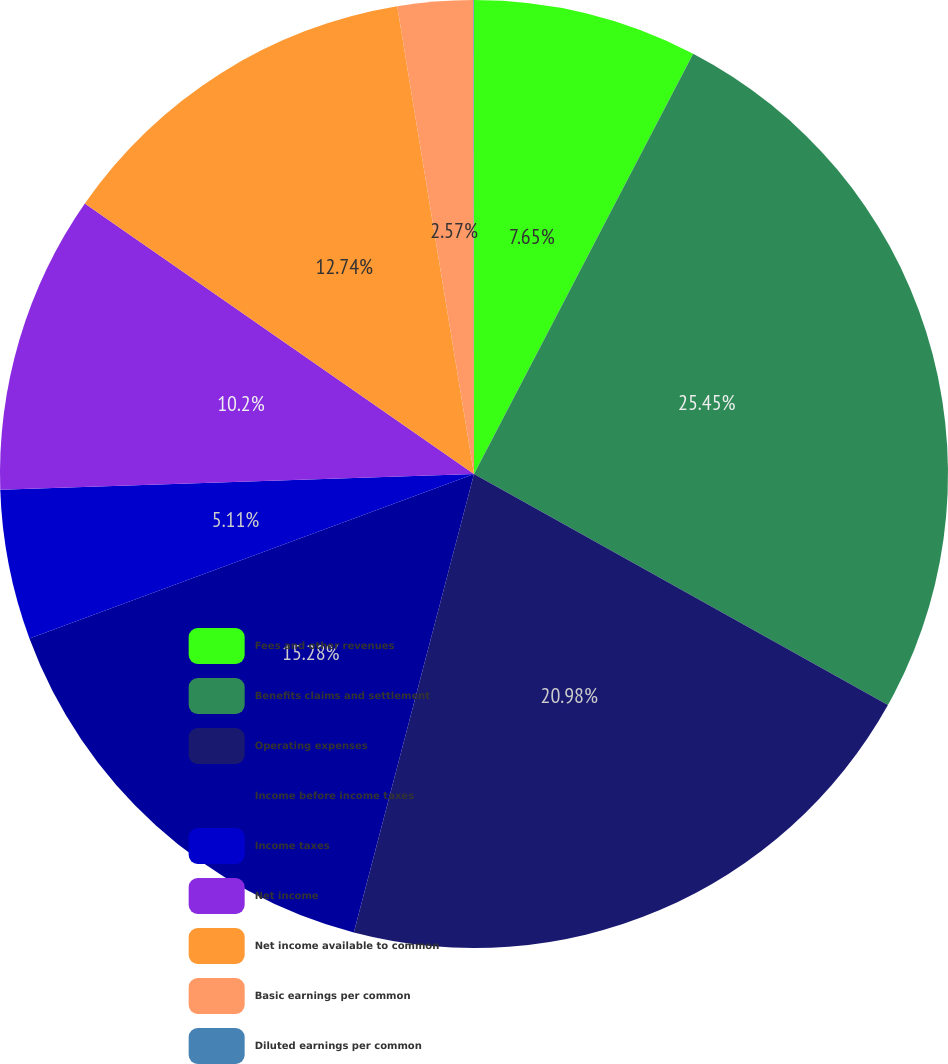Convert chart to OTSL. <chart><loc_0><loc_0><loc_500><loc_500><pie_chart><fcel>Fees and other revenues<fcel>Benefits claims and settlement<fcel>Operating expenses<fcel>Income before income taxes<fcel>Income taxes<fcel>Net income<fcel>Net income available to common<fcel>Basic earnings per common<fcel>Diluted earnings per common<nl><fcel>7.65%<fcel>25.45%<fcel>20.98%<fcel>15.28%<fcel>5.11%<fcel>10.2%<fcel>12.74%<fcel>2.57%<fcel>0.02%<nl></chart> 